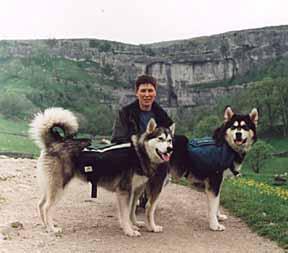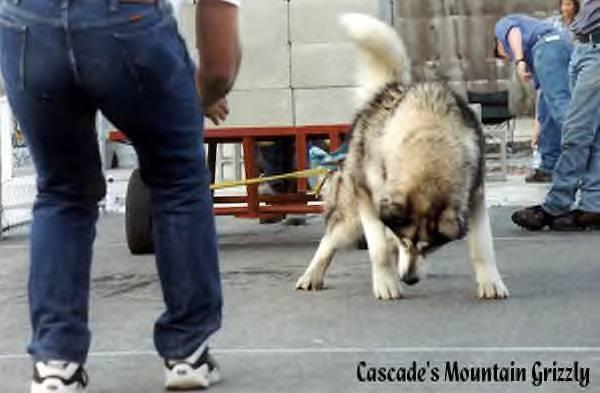The first image is the image on the left, the second image is the image on the right. For the images displayed, is the sentence "In at least one image there is a single dog facing left that is trying to pull a stack of cement bricks." factually correct? Answer yes or no. No. The first image is the image on the left, the second image is the image on the right. Considering the images on both sides, is "At least one of the dogs in the image on the left is wearing a vest." valid? Answer yes or no. Yes. 